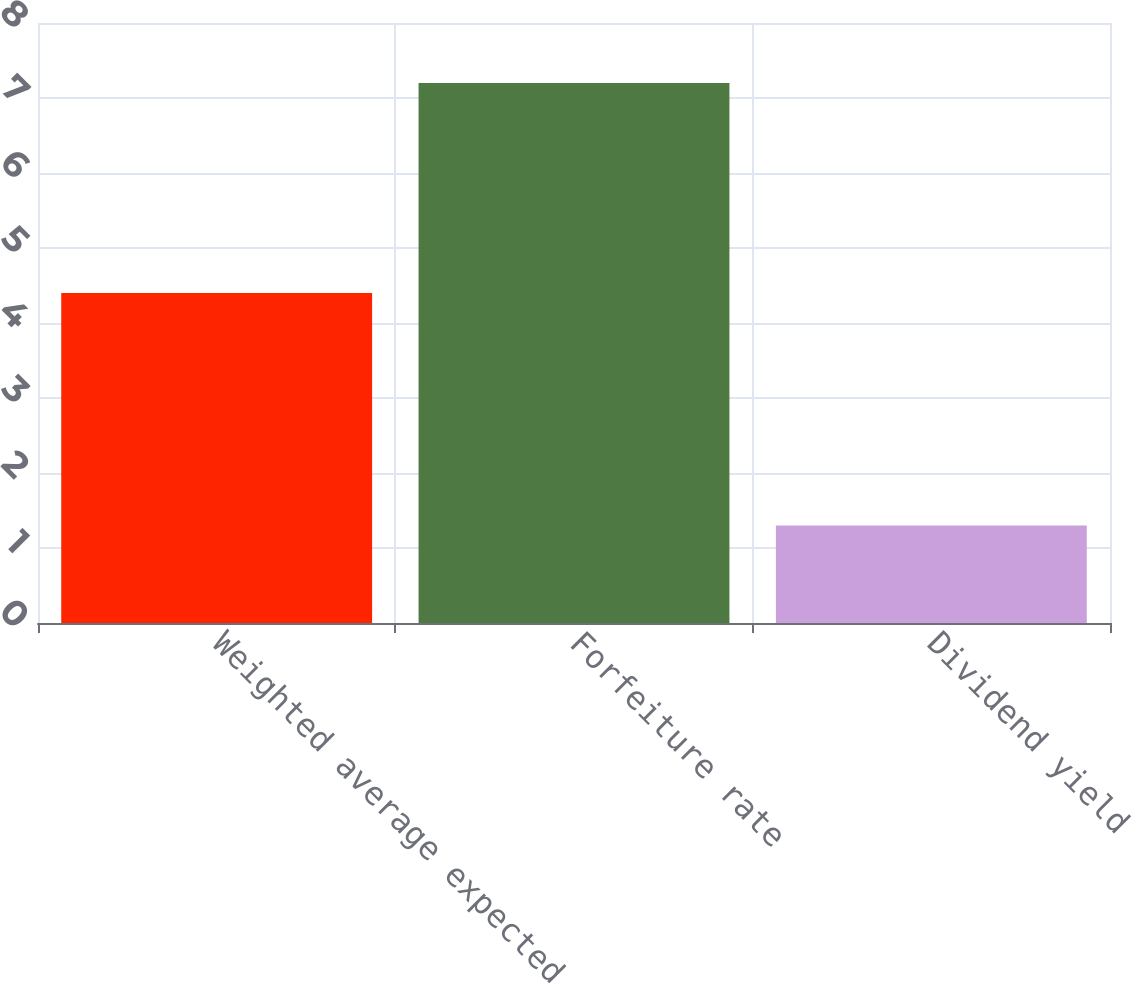<chart> <loc_0><loc_0><loc_500><loc_500><bar_chart><fcel>Weighted average expected<fcel>Forfeiture rate<fcel>Dividend yield<nl><fcel>4.4<fcel>7.2<fcel>1.3<nl></chart> 